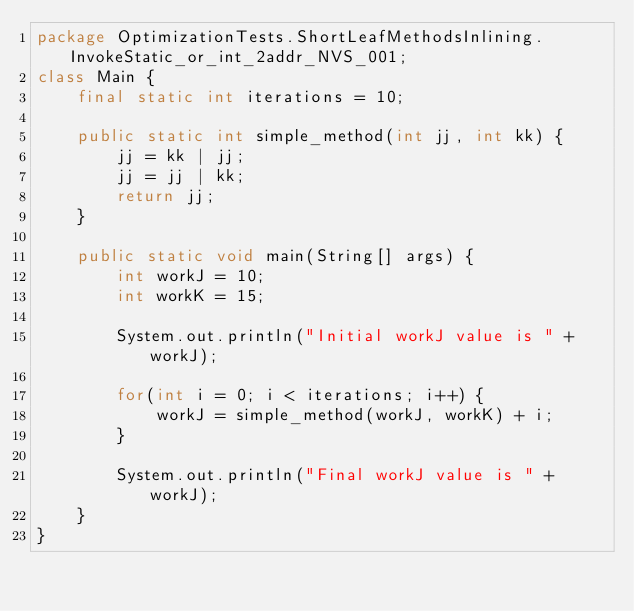Convert code to text. <code><loc_0><loc_0><loc_500><loc_500><_Java_>package OptimizationTests.ShortLeafMethodsInlining.InvokeStatic_or_int_2addr_NVS_001;
class Main {
    final static int iterations = 10;

    public static int simple_method(int jj, int kk) {
        jj = kk | jj;
        jj = jj | kk;
        return jj;
    }

    public static void main(String[] args) {
        int workJ = 10;
        int workK = 15;

        System.out.println("Initial workJ value is " + workJ);

        for(int i = 0; i < iterations; i++) {
            workJ = simple_method(workJ, workK) + i;
        }

        System.out.println("Final workJ value is " + workJ);
    }
}
</code> 